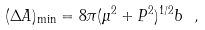<formula> <loc_0><loc_0><loc_500><loc_500>( \Delta A ) _ { \min } = 8 \pi ( \mu ^ { 2 } + P ^ { 2 } ) ^ { 1 / 2 } b \ ,</formula> 